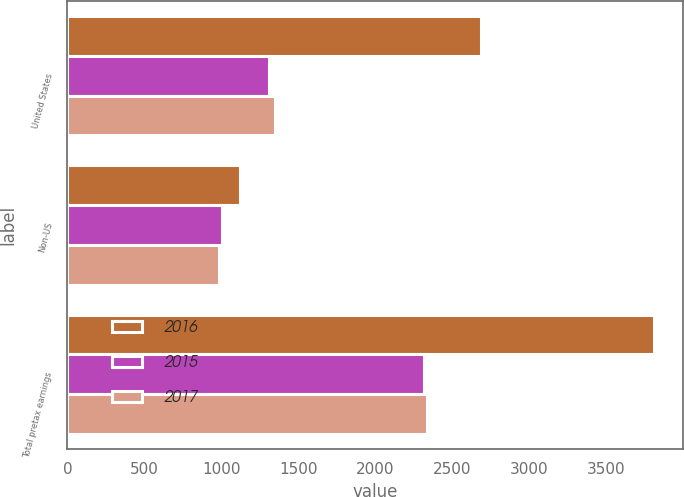Convert chart. <chart><loc_0><loc_0><loc_500><loc_500><stacked_bar_chart><ecel><fcel>United States<fcel>Non-US<fcel>Total pretax earnings<nl><fcel>2016<fcel>2688<fcel>1119<fcel>3807<nl><fcel>2015<fcel>1312<fcel>1004<fcel>2316<nl><fcel>2017<fcel>1350<fcel>985<fcel>2335<nl></chart> 